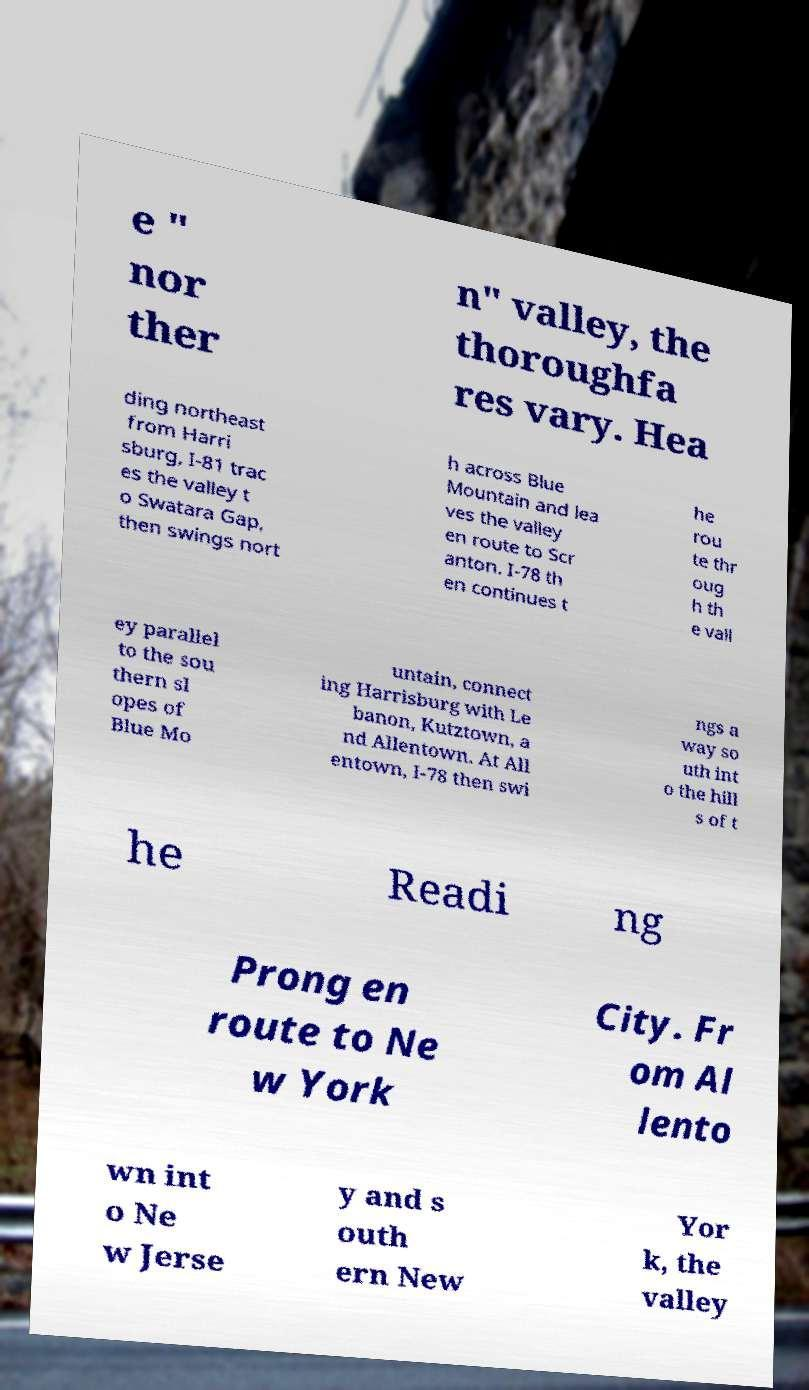Can you accurately transcribe the text from the provided image for me? e " nor ther n" valley, the thoroughfa res vary. Hea ding northeast from Harri sburg, I-81 trac es the valley t o Swatara Gap, then swings nort h across Blue Mountain and lea ves the valley en route to Scr anton. I-78 th en continues t he rou te thr oug h th e vall ey parallel to the sou thern sl opes of Blue Mo untain, connect ing Harrisburg with Le banon, Kutztown, a nd Allentown. At All entown, I-78 then swi ngs a way so uth int o the hill s of t he Readi ng Prong en route to Ne w York City. Fr om Al lento wn int o Ne w Jerse y and s outh ern New Yor k, the valley 